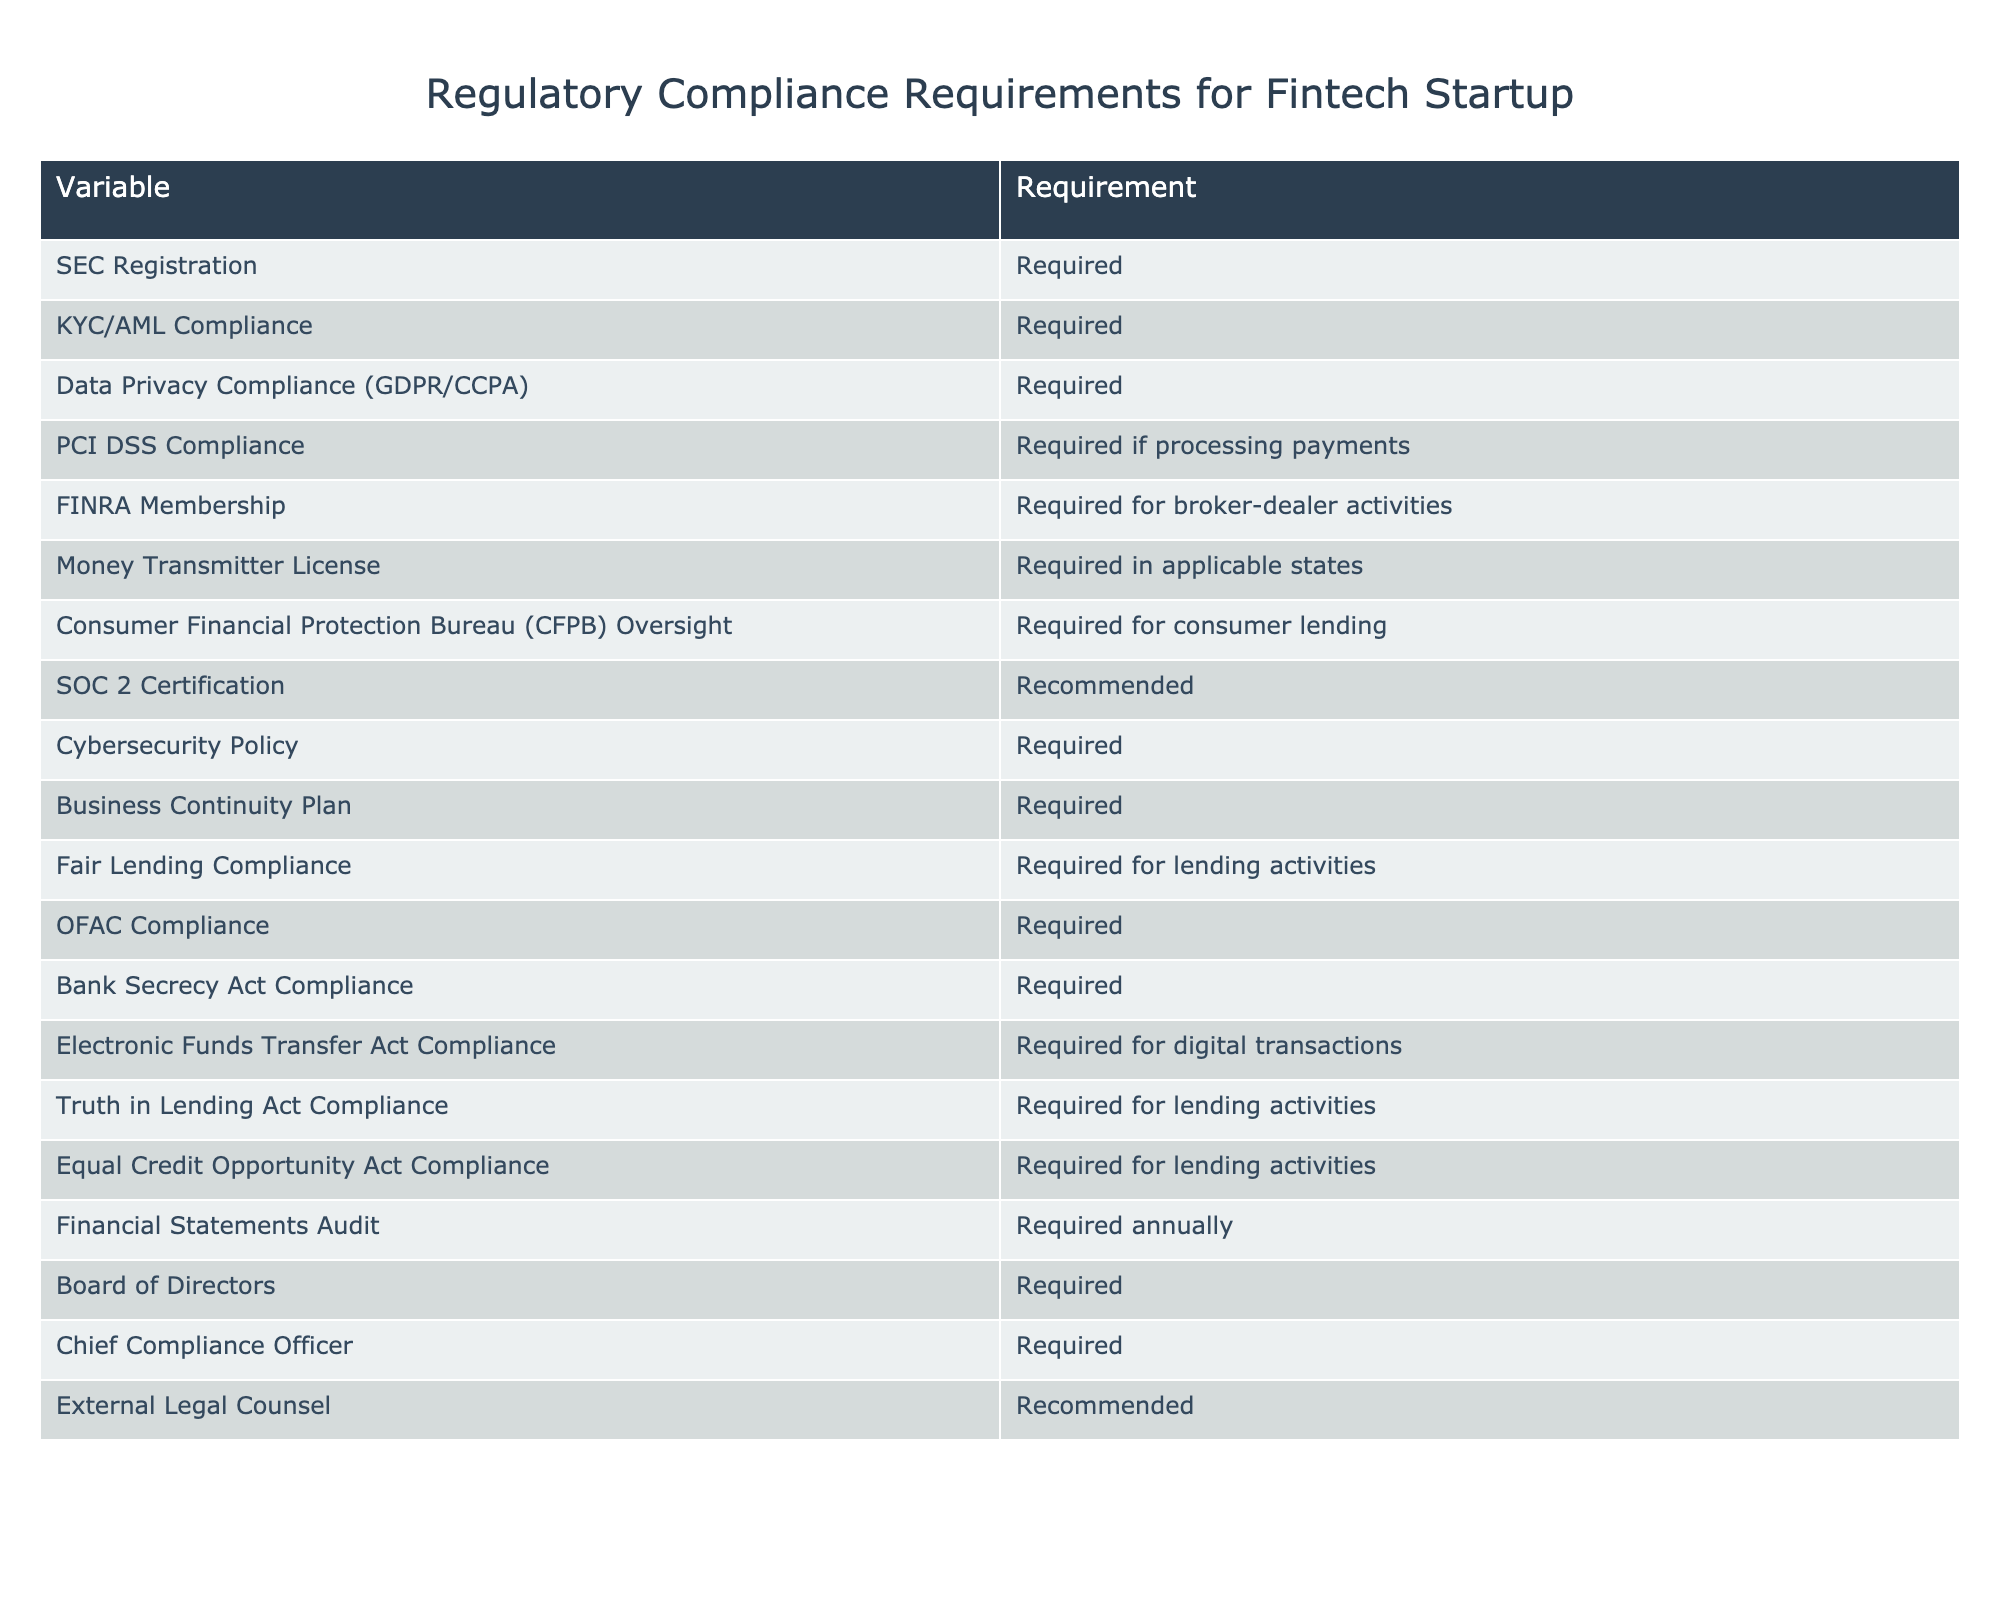What is required for KYC/AML Compliance? According to the table, KYC/AML Compliance is marked as "Required," indicating that the startup must implement systems and processes to comply with Know Your Customer (KYC) and Anti-Money Laundering (AML) regulations.
Answer: Required Is SOC 2 Certification mandatory? The table indicates that SOC 2 Certification is "Recommended," not required. This means while it's a good practice for the startup to obtain this certification, it's not a legal requirement.
Answer: No How many compliance requirements are categorized as 'Required'? The table lists 15 compliance requirements in total. By counting the ones marked as "Required," it becomes clear that there are 12 such requirements.
Answer: 12 Do we need a Chief Compliance Officer? The table explicitly states that a Chief Compliance Officer is "Required," which signifies the necessity of having an individual responsible for ensuring compliance with regulatory standards.
Answer: Yes Which compliance requirements are associated specifically with lending activities? There are three requirements noted in the table that relate directly to lending activities: Fair Lending Compliance, Truth in Lending Act Compliance, and Equal Credit Opportunity Act Compliance.
Answer: Fair Lending Compliance, Truth in Lending Act Compliance, Equal Credit Opportunity Act Compliance If a startup is processing payments, which compliance requirement applies? The table specifies that PCI DSS Compliance is "Required if processing payments." This means that compliance with the Payment Card Industry Data Security Standard is a must if the startup processes payment transactions.
Answer: Required if processing payments What are the requirements specifically related to federal oversight? The table highlights two key requirements associated with federal oversight: SEC Registration and Consumer Financial Protection Bureau (CFPB) Oversight. These indicate necessary regulatory frameworks for the operations of the startup.
Answer: SEC Registration, CFPB Oversight How many recommendations versus mandatory requirements are present in the table? In total, there are 15 compliance requirements listed. Among these, 12 are marked as "Required," while 3 are classified as "Recommended," leading to the conclusion that there are more mandatory requirements than recommendations.
Answer: 12 mandatory requirements, 3 recommendations Is a Money Transmitter License necessary for all states? The table states that a Money Transmitter License is "Required in applicable states," which indicates that the requirement is not universal for all states, but rather depends on specific state regulations applicable to the startup's operations.
Answer: No 